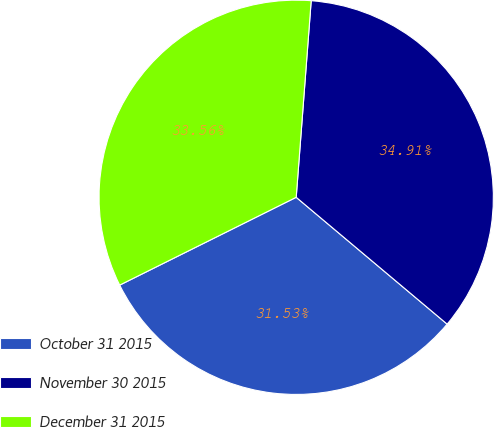Convert chart to OTSL. <chart><loc_0><loc_0><loc_500><loc_500><pie_chart><fcel>October 31 2015<fcel>November 30 2015<fcel>December 31 2015<nl><fcel>31.53%<fcel>34.91%<fcel>33.56%<nl></chart> 